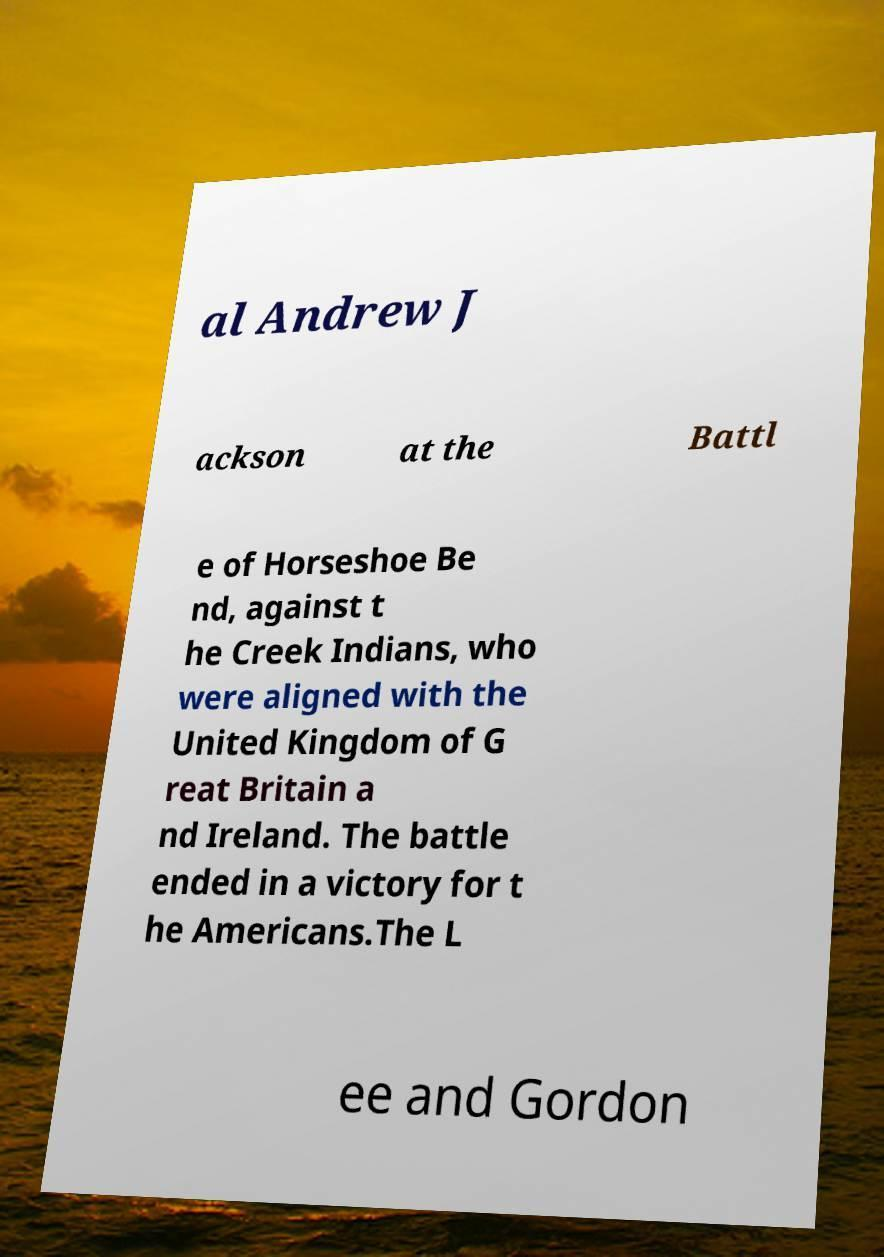Please identify and transcribe the text found in this image. al Andrew J ackson at the Battl e of Horseshoe Be nd, against t he Creek Indians, who were aligned with the United Kingdom of G reat Britain a nd Ireland. The battle ended in a victory for t he Americans.The L ee and Gordon 